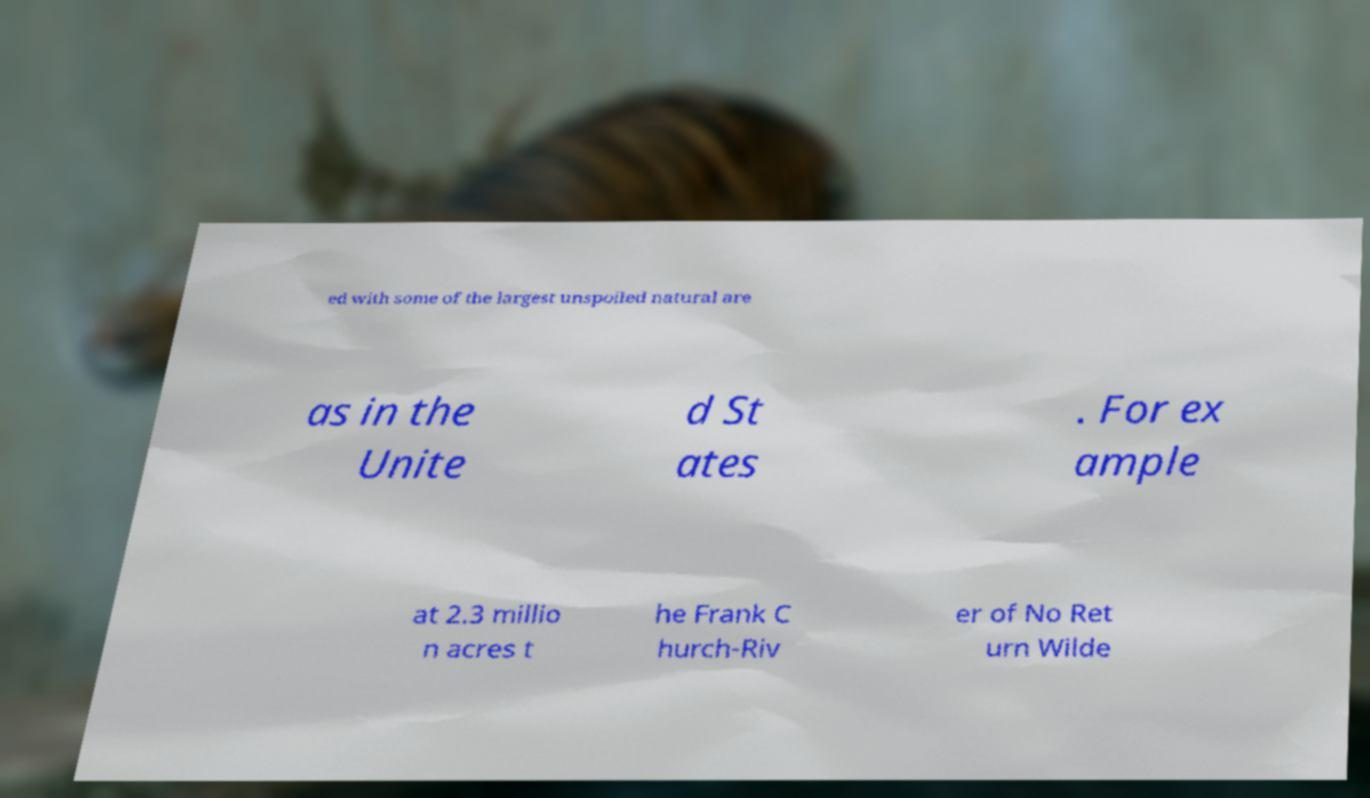What messages or text are displayed in this image? I need them in a readable, typed format. ed with some of the largest unspoiled natural are as in the Unite d St ates . For ex ample at 2.3 millio n acres t he Frank C hurch-Riv er of No Ret urn Wilde 